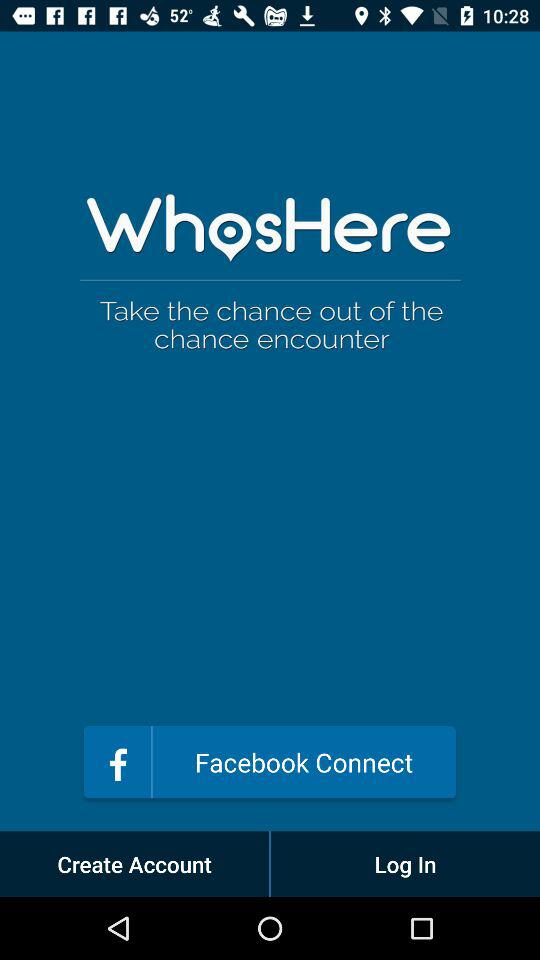How can we connect? You can connect with "Facebook". 